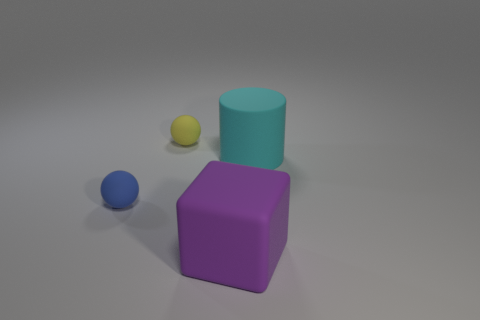Add 4 big matte cubes. How many objects exist? 8 Add 2 small matte spheres. How many small matte spheres are left? 4 Add 1 blue blocks. How many blue blocks exist? 1 Subtract 0 cyan spheres. How many objects are left? 4 Subtract all large cyan rubber cylinders. Subtract all large cyan metallic balls. How many objects are left? 3 